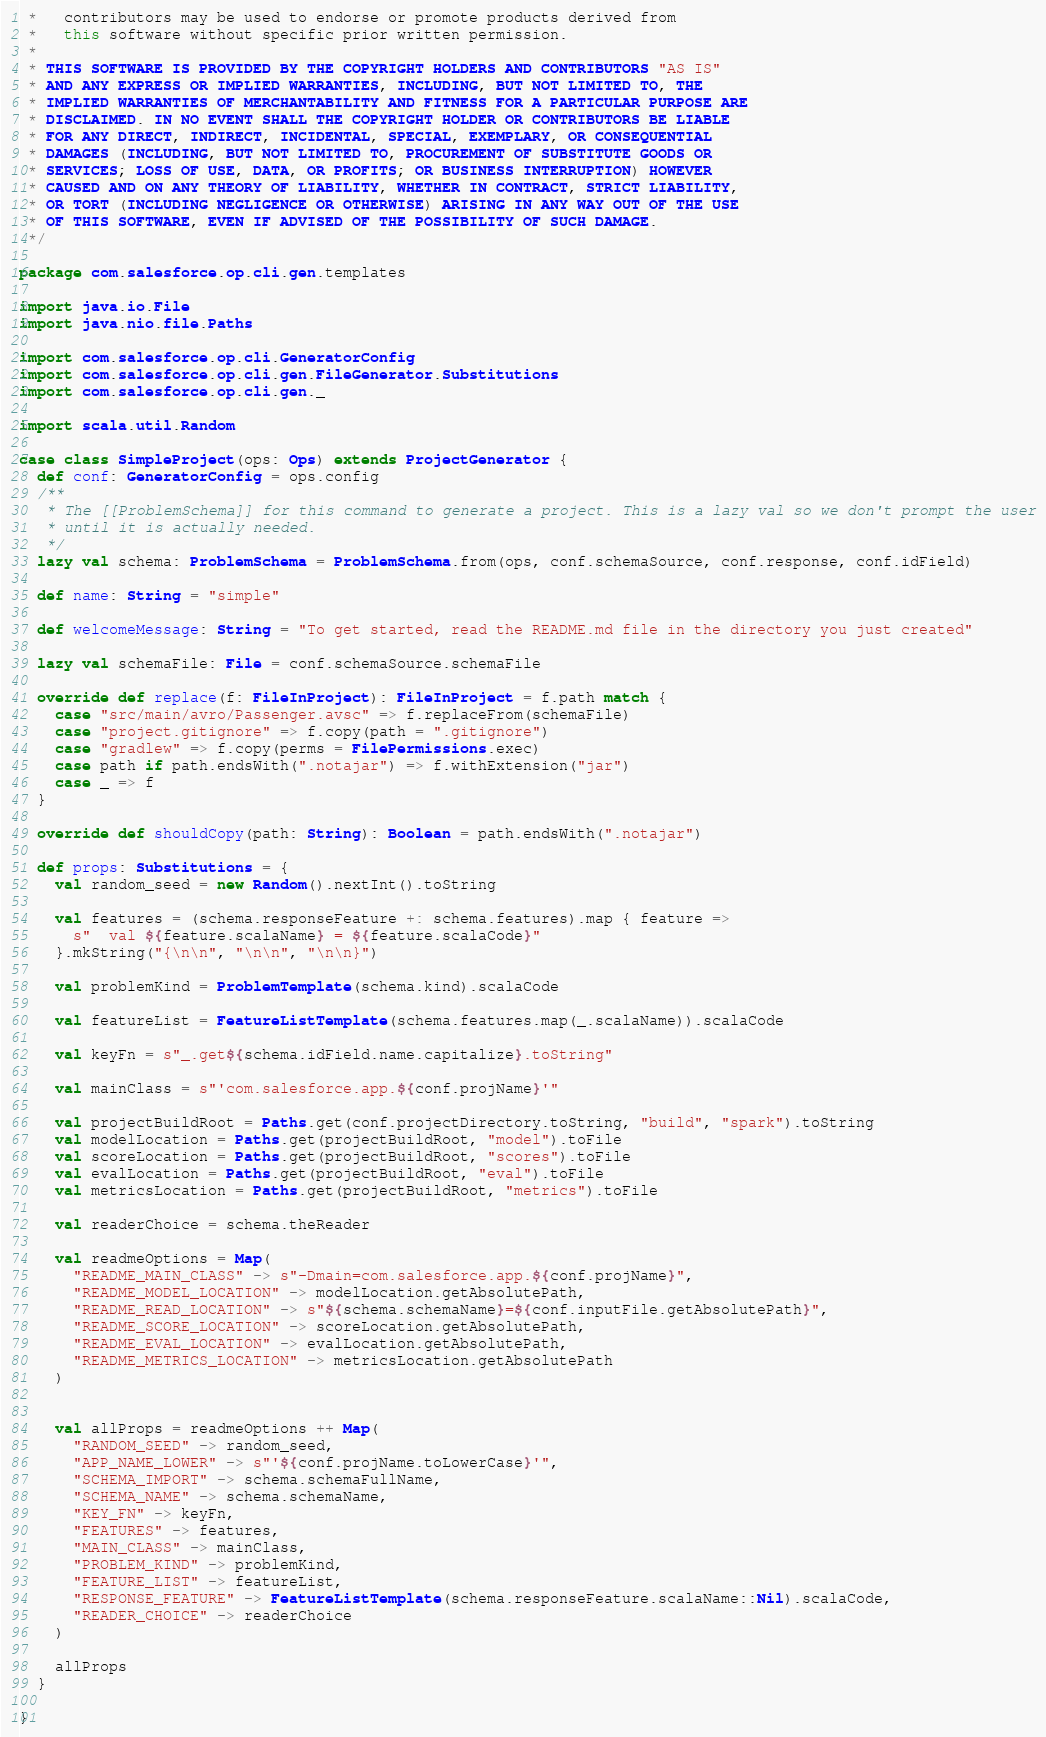Convert code to text. <code><loc_0><loc_0><loc_500><loc_500><_Scala_> *   contributors may be used to endorse or promote products derived from
 *   this software without specific prior written permission.
 *
 * THIS SOFTWARE IS PROVIDED BY THE COPYRIGHT HOLDERS AND CONTRIBUTORS "AS IS"
 * AND ANY EXPRESS OR IMPLIED WARRANTIES, INCLUDING, BUT NOT LIMITED TO, THE
 * IMPLIED WARRANTIES OF MERCHANTABILITY AND FITNESS FOR A PARTICULAR PURPOSE ARE
 * DISCLAIMED. IN NO EVENT SHALL THE COPYRIGHT HOLDER OR CONTRIBUTORS BE LIABLE
 * FOR ANY DIRECT, INDIRECT, INCIDENTAL, SPECIAL, EXEMPLARY, OR CONSEQUENTIAL
 * DAMAGES (INCLUDING, BUT NOT LIMITED TO, PROCUREMENT OF SUBSTITUTE GOODS OR
 * SERVICES; LOSS OF USE, DATA, OR PROFITS; OR BUSINESS INTERRUPTION) HOWEVER
 * CAUSED AND ON ANY THEORY OF LIABILITY, WHETHER IN CONTRACT, STRICT LIABILITY,
 * OR TORT (INCLUDING NEGLIGENCE OR OTHERWISE) ARISING IN ANY WAY OUT OF THE USE
 * OF THIS SOFTWARE, EVEN IF ADVISED OF THE POSSIBILITY OF SUCH DAMAGE.
 */

package com.salesforce.op.cli.gen.templates

import java.io.File
import java.nio.file.Paths

import com.salesforce.op.cli.GeneratorConfig
import com.salesforce.op.cli.gen.FileGenerator.Substitutions
import com.salesforce.op.cli.gen._

import scala.util.Random

case class SimpleProject(ops: Ops) extends ProjectGenerator {
  def conf: GeneratorConfig = ops.config
  /**
   * The [[ProblemSchema]] for this command to generate a project. This is a lazy val so we don't prompt the user
   * until it is actually needed.
   */
  lazy val schema: ProblemSchema = ProblemSchema.from(ops, conf.schemaSource, conf.response, conf.idField)

  def name: String = "simple"

  def welcomeMessage: String = "To get started, read the README.md file in the directory you just created"

  lazy val schemaFile: File = conf.schemaSource.schemaFile

  override def replace(f: FileInProject): FileInProject = f.path match {
    case "src/main/avro/Passenger.avsc" => f.replaceFrom(schemaFile)
    case "project.gitignore" => f.copy(path = ".gitignore")
    case "gradlew" => f.copy(perms = FilePermissions.exec)
    case path if path.endsWith(".notajar") => f.withExtension("jar")
    case _ => f
  }

  override def shouldCopy(path: String): Boolean = path.endsWith(".notajar")

  def props: Substitutions = {
    val random_seed = new Random().nextInt().toString

    val features = (schema.responseFeature +: schema.features).map { feature =>
      s"  val ${feature.scalaName} = ${feature.scalaCode}"
    }.mkString("{\n\n", "\n\n", "\n\n}")

    val problemKind = ProblemTemplate(schema.kind).scalaCode

    val featureList = FeatureListTemplate(schema.features.map(_.scalaName)).scalaCode

    val keyFn = s"_.get${schema.idField.name.capitalize}.toString"

    val mainClass = s"'com.salesforce.app.${conf.projName}'"

    val projectBuildRoot = Paths.get(conf.projectDirectory.toString, "build", "spark").toString
    val modelLocation = Paths.get(projectBuildRoot, "model").toFile
    val scoreLocation = Paths.get(projectBuildRoot, "scores").toFile
    val evalLocation = Paths.get(projectBuildRoot, "eval").toFile
    val metricsLocation = Paths.get(projectBuildRoot, "metrics").toFile

    val readerChoice = schema.theReader

    val readmeOptions = Map(
      "README_MAIN_CLASS" -> s"-Dmain=com.salesforce.app.${conf.projName}",
      "README_MODEL_LOCATION" -> modelLocation.getAbsolutePath,
      "README_READ_LOCATION" -> s"${schema.schemaName}=${conf.inputFile.getAbsolutePath}",
      "README_SCORE_LOCATION" -> scoreLocation.getAbsolutePath,
      "README_EVAL_LOCATION" -> evalLocation.getAbsolutePath,
      "README_METRICS_LOCATION" -> metricsLocation.getAbsolutePath
    )


    val allProps = readmeOptions ++ Map(
      "RANDOM_SEED" -> random_seed,
      "APP_NAME_LOWER" -> s"'${conf.projName.toLowerCase}'",
      "SCHEMA_IMPORT" -> schema.schemaFullName,
      "SCHEMA_NAME" -> schema.schemaName,
      "KEY_FN" -> keyFn,
      "FEATURES" -> features,
      "MAIN_CLASS" -> mainClass,
      "PROBLEM_KIND" -> problemKind,
      "FEATURE_LIST" -> featureList,
      "RESPONSE_FEATURE" -> FeatureListTemplate(schema.responseFeature.scalaName::Nil).scalaCode,
      "READER_CHOICE" -> readerChoice
    )

    allProps
  }

}
</code> 